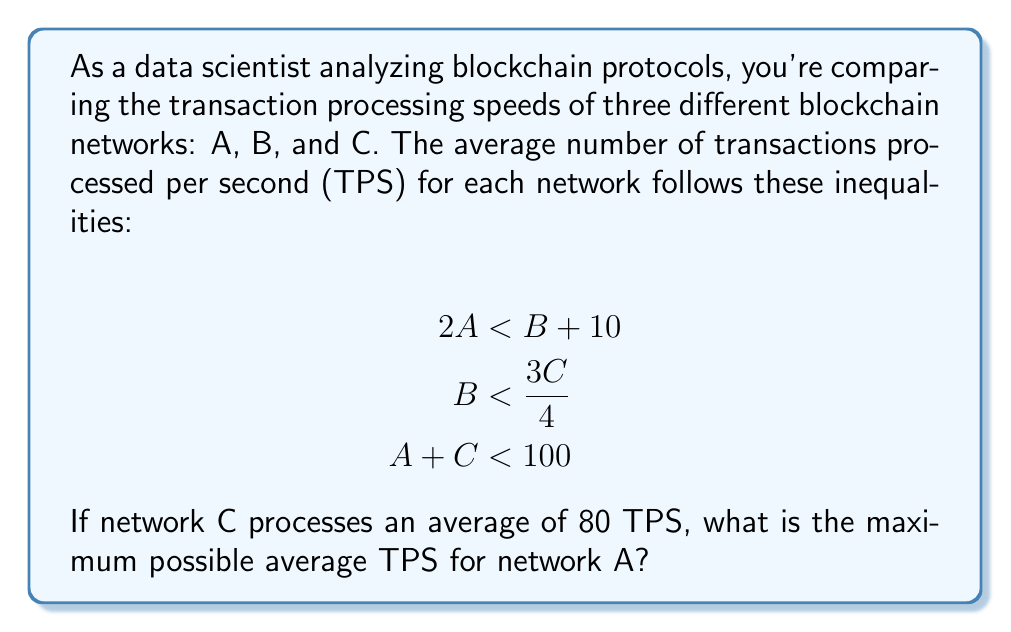What is the answer to this math problem? Let's approach this step-by-step:

1) We're given that network C processes 80 TPS on average. Let's substitute this into the third inequality:

   $$ A + 80 < 100 $$

2) Solving for A:

   $$ A < 100 - 80 = 20 $$

3) Now, let's look at the second inequality. We can substitute C = 80:

   $$ B < \frac{3(80)}{4} = 60 $$

4) Using this information in the first inequality:

   $$ 2A < B + 10 < 60 + 10 = 70 $$

5) Solving for A:

   $$ A < 35 $$

6) Comparing the results from steps 2 and 5, we see that A must be less than both 20 and 35. The stricter condition is A < 20.

7) Since we're asked for the maximum possible TPS for network A, and A must be strictly less than 20, the maximum value would be just under 20.

In practical terms, since TPS is typically expressed as an integer, the maximum would be 19 TPS.
Answer: 19 TPS 